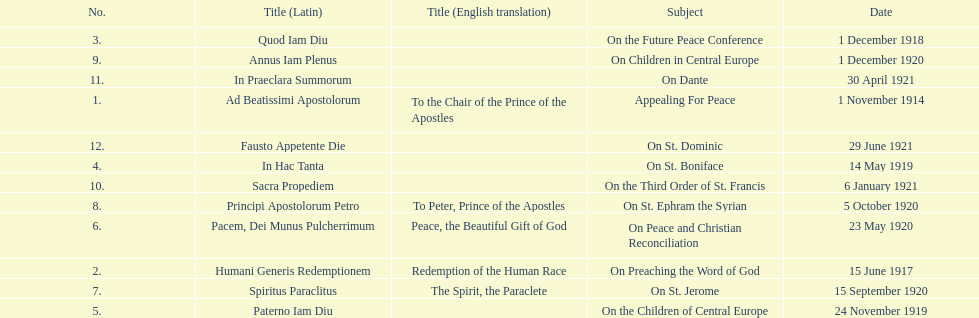How long after quod iam diu was paterno iam diu issued? 11 months. 